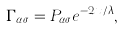Convert formula to latex. <formula><loc_0><loc_0><loc_500><loc_500>\Gamma _ { \alpha \sigma } = P _ { \alpha \sigma } e ^ { - 2 x / \lambda } ,</formula> 